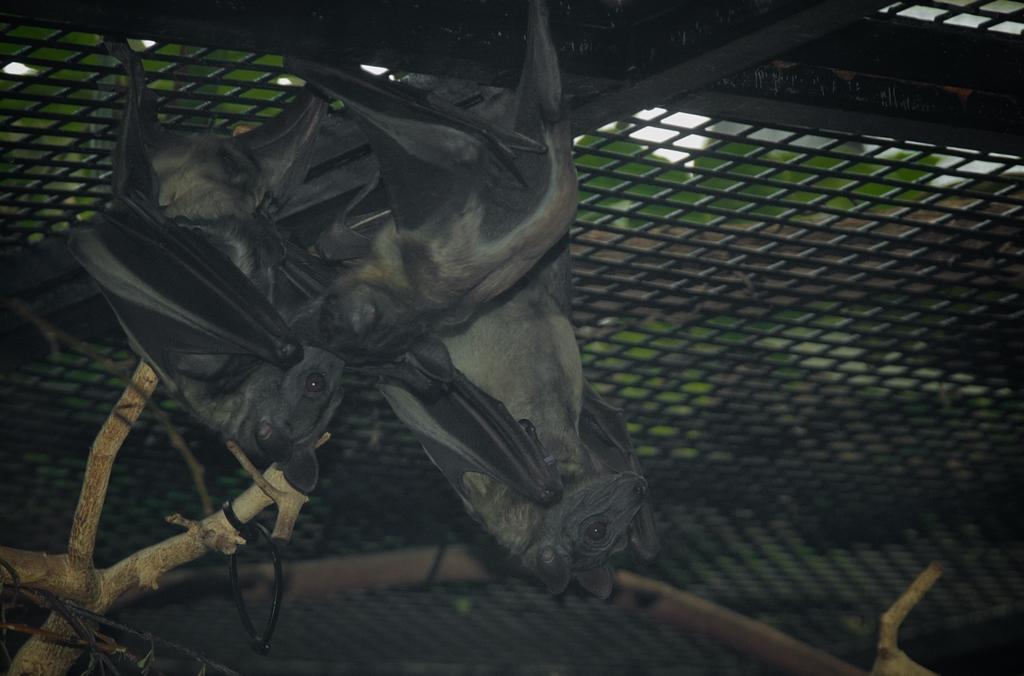In one or two sentences, can you explain what this image depicts? In this image I can see there few bats visible attached to the fence, there is a wooden stem visible in the bottom left. 